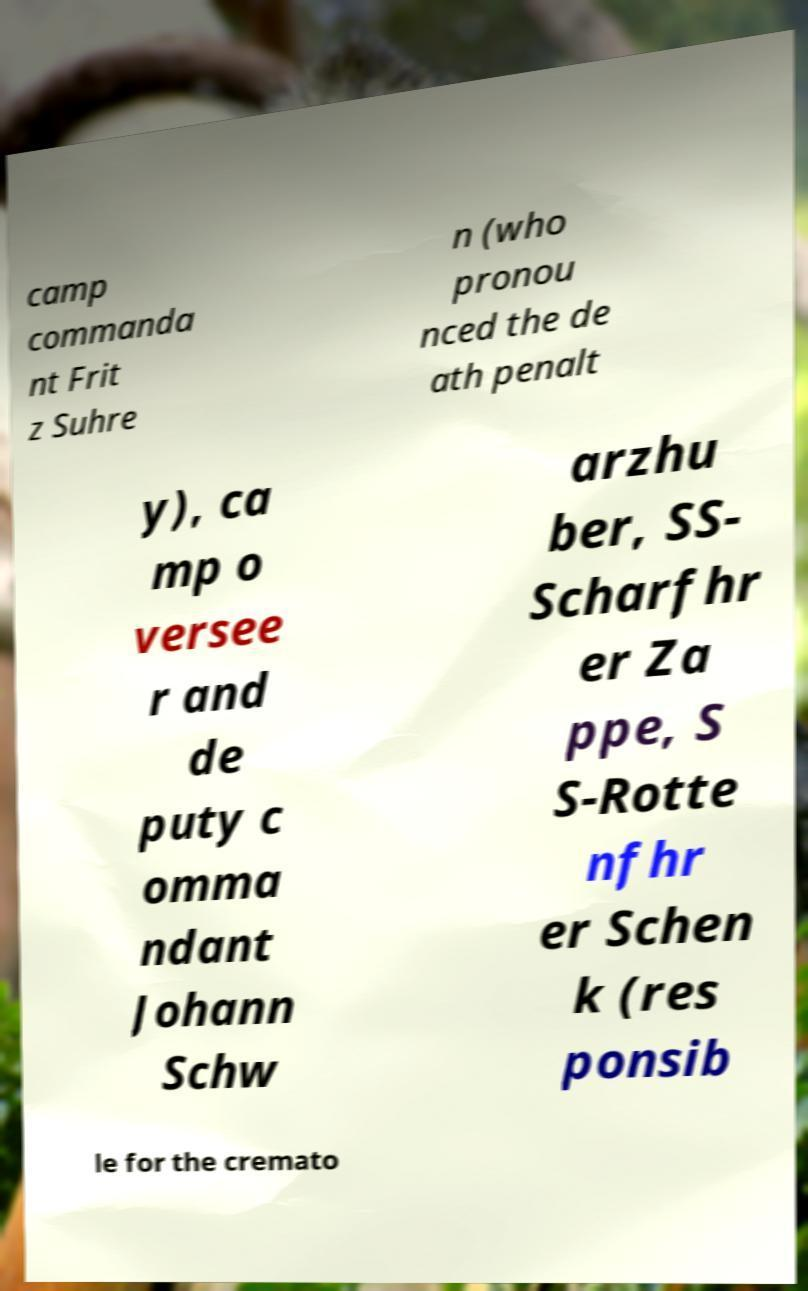For documentation purposes, I need the text within this image transcribed. Could you provide that? camp commanda nt Frit z Suhre n (who pronou nced the de ath penalt y), ca mp o versee r and de puty c omma ndant Johann Schw arzhu ber, SS- Scharfhr er Za ppe, S S-Rotte nfhr er Schen k (res ponsib le for the cremato 